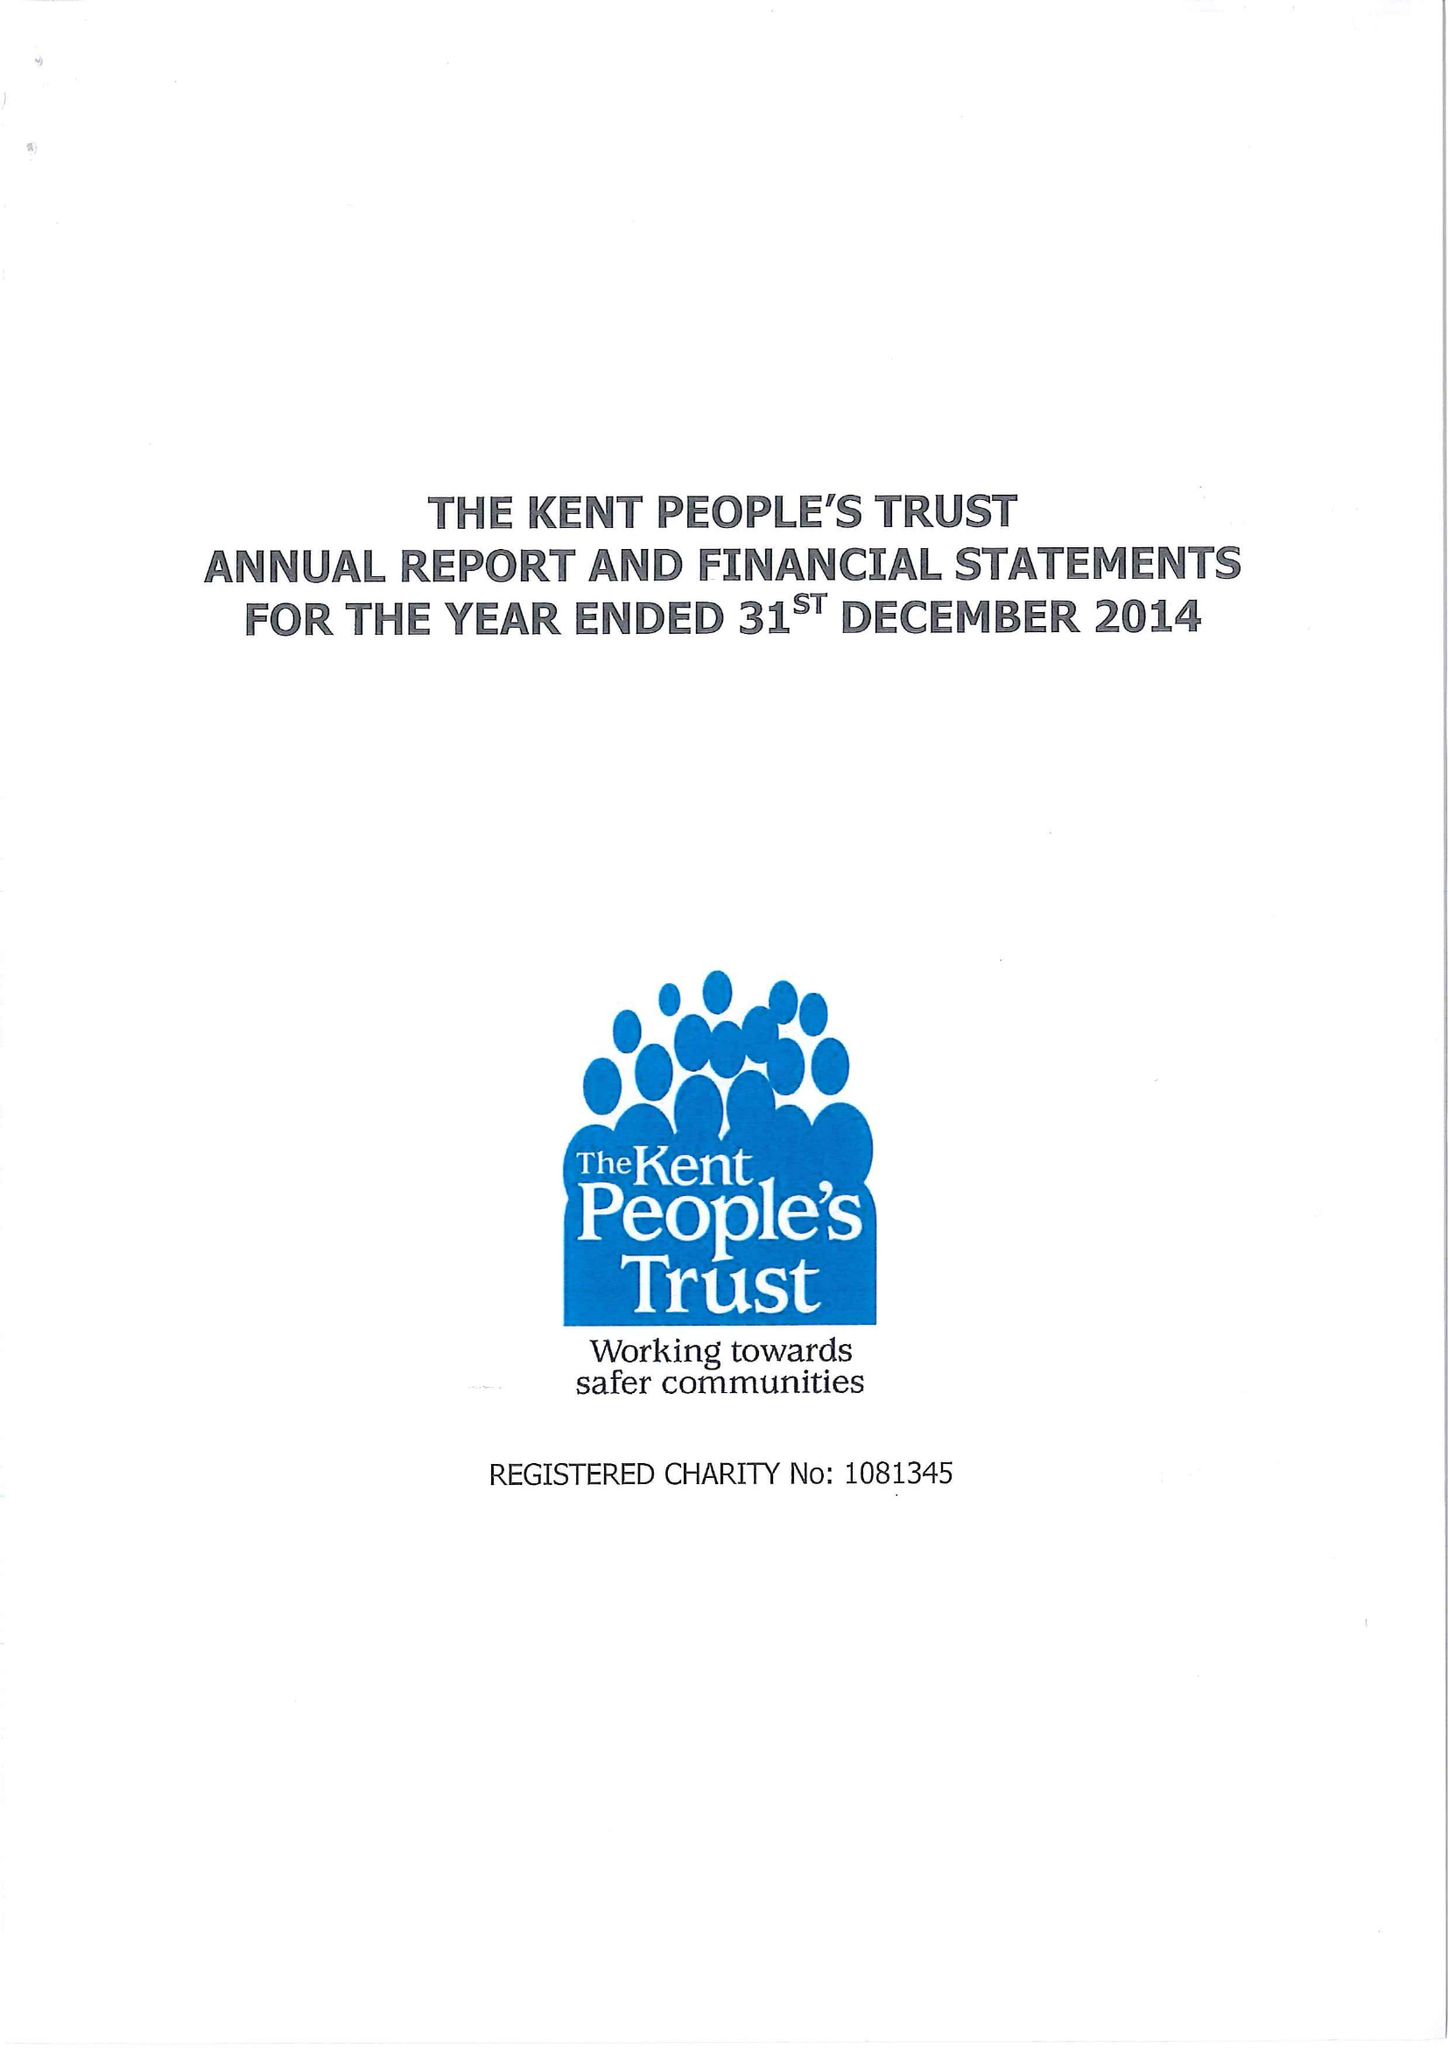What is the value for the charity_number?
Answer the question using a single word or phrase. 1081345 